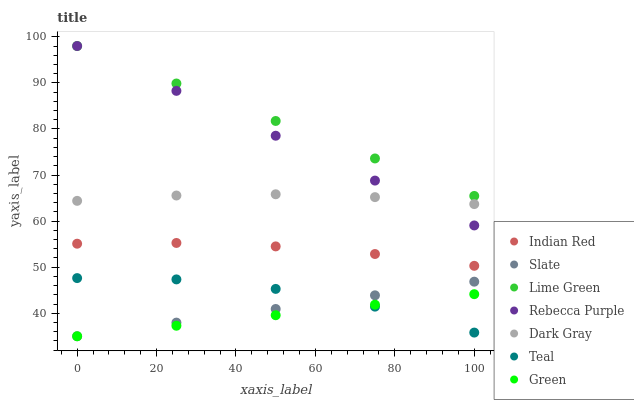Does Green have the minimum area under the curve?
Answer yes or no. Yes. Does Lime Green have the maximum area under the curve?
Answer yes or no. Yes. Does Slate have the minimum area under the curve?
Answer yes or no. No. Does Slate have the maximum area under the curve?
Answer yes or no. No. Is Rebecca Purple the smoothest?
Answer yes or no. Yes. Is Teal the roughest?
Answer yes or no. Yes. Is Slate the smoothest?
Answer yes or no. No. Is Slate the roughest?
Answer yes or no. No. Does Slate have the lowest value?
Answer yes or no. Yes. Does Dark Gray have the lowest value?
Answer yes or no. No. Does Lime Green have the highest value?
Answer yes or no. Yes. Does Slate have the highest value?
Answer yes or no. No. Is Teal less than Dark Gray?
Answer yes or no. Yes. Is Lime Green greater than Teal?
Answer yes or no. Yes. Does Slate intersect Green?
Answer yes or no. Yes. Is Slate less than Green?
Answer yes or no. No. Is Slate greater than Green?
Answer yes or no. No. Does Teal intersect Dark Gray?
Answer yes or no. No. 